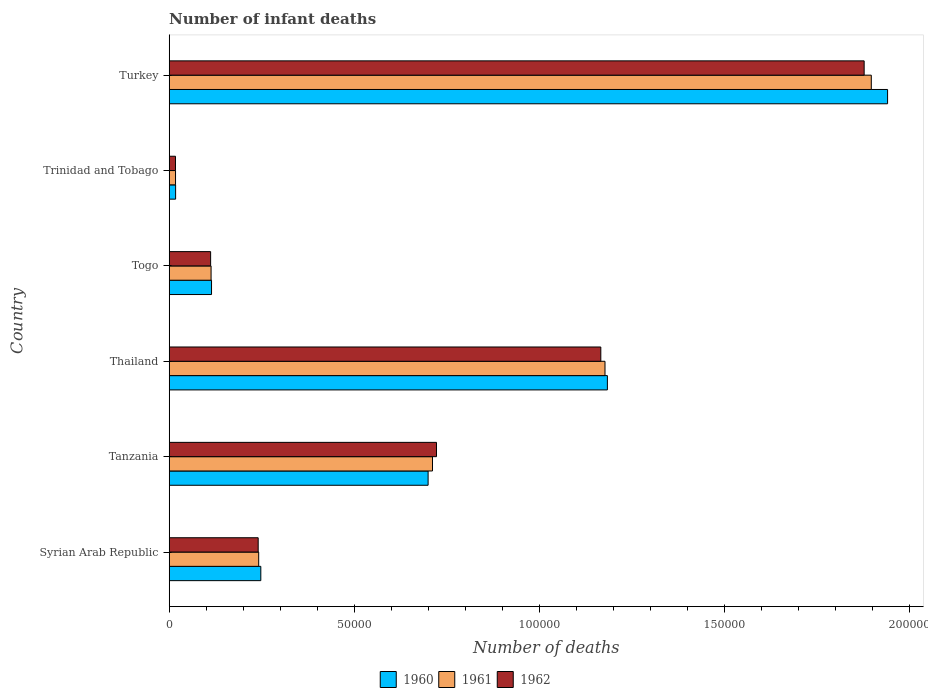How many bars are there on the 2nd tick from the bottom?
Offer a terse response. 3. What is the label of the 2nd group of bars from the top?
Offer a very short reply. Trinidad and Tobago. In how many cases, is the number of bars for a given country not equal to the number of legend labels?
Your answer should be very brief. 0. What is the number of infant deaths in 1961 in Turkey?
Provide a succinct answer. 1.90e+05. Across all countries, what is the maximum number of infant deaths in 1960?
Ensure brevity in your answer.  1.94e+05. Across all countries, what is the minimum number of infant deaths in 1960?
Your answer should be very brief. 1728. In which country was the number of infant deaths in 1962 minimum?
Offer a terse response. Trinidad and Tobago. What is the total number of infant deaths in 1961 in the graph?
Offer a terse response. 4.16e+05. What is the difference between the number of infant deaths in 1961 in Tanzania and that in Trinidad and Tobago?
Ensure brevity in your answer.  6.94e+04. What is the difference between the number of infant deaths in 1960 in Thailand and the number of infant deaths in 1961 in Trinidad and Tobago?
Keep it short and to the point. 1.17e+05. What is the average number of infant deaths in 1961 per country?
Your answer should be compact. 6.93e+04. What is the difference between the number of infant deaths in 1961 and number of infant deaths in 1962 in Tanzania?
Your answer should be compact. -1080. What is the ratio of the number of infant deaths in 1960 in Syrian Arab Republic to that in Thailand?
Offer a very short reply. 0.21. Is the number of infant deaths in 1962 in Syrian Arab Republic less than that in Trinidad and Tobago?
Your response must be concise. No. Is the difference between the number of infant deaths in 1961 in Syrian Arab Republic and Turkey greater than the difference between the number of infant deaths in 1962 in Syrian Arab Republic and Turkey?
Your answer should be compact. No. What is the difference between the highest and the second highest number of infant deaths in 1962?
Offer a very short reply. 7.11e+04. What is the difference between the highest and the lowest number of infant deaths in 1962?
Make the answer very short. 1.86e+05. In how many countries, is the number of infant deaths in 1961 greater than the average number of infant deaths in 1961 taken over all countries?
Keep it short and to the point. 3. Is the sum of the number of infant deaths in 1960 in Tanzania and Trinidad and Tobago greater than the maximum number of infant deaths in 1962 across all countries?
Provide a succinct answer. No. Is it the case that in every country, the sum of the number of infant deaths in 1960 and number of infant deaths in 1961 is greater than the number of infant deaths in 1962?
Offer a terse response. Yes. Are all the bars in the graph horizontal?
Offer a very short reply. Yes. Does the graph contain grids?
Your response must be concise. No. Where does the legend appear in the graph?
Offer a very short reply. Bottom center. What is the title of the graph?
Make the answer very short. Number of infant deaths. What is the label or title of the X-axis?
Offer a terse response. Number of deaths. What is the label or title of the Y-axis?
Give a very brief answer. Country. What is the Number of deaths in 1960 in Syrian Arab Republic?
Provide a succinct answer. 2.47e+04. What is the Number of deaths in 1961 in Syrian Arab Republic?
Offer a very short reply. 2.42e+04. What is the Number of deaths in 1962 in Syrian Arab Republic?
Offer a very short reply. 2.40e+04. What is the Number of deaths of 1960 in Tanzania?
Make the answer very short. 6.99e+04. What is the Number of deaths of 1961 in Tanzania?
Keep it short and to the point. 7.11e+04. What is the Number of deaths of 1962 in Tanzania?
Your response must be concise. 7.22e+04. What is the Number of deaths in 1960 in Thailand?
Provide a succinct answer. 1.18e+05. What is the Number of deaths in 1961 in Thailand?
Give a very brief answer. 1.18e+05. What is the Number of deaths in 1962 in Thailand?
Offer a very short reply. 1.17e+05. What is the Number of deaths of 1960 in Togo?
Your answer should be compact. 1.14e+04. What is the Number of deaths of 1961 in Togo?
Your answer should be compact. 1.13e+04. What is the Number of deaths in 1962 in Togo?
Your answer should be compact. 1.12e+04. What is the Number of deaths in 1960 in Trinidad and Tobago?
Offer a very short reply. 1728. What is the Number of deaths in 1961 in Trinidad and Tobago?
Your response must be concise. 1710. What is the Number of deaths of 1962 in Trinidad and Tobago?
Offer a very short reply. 1698. What is the Number of deaths of 1960 in Turkey?
Make the answer very short. 1.94e+05. What is the Number of deaths in 1961 in Turkey?
Your answer should be very brief. 1.90e+05. What is the Number of deaths in 1962 in Turkey?
Provide a succinct answer. 1.88e+05. Across all countries, what is the maximum Number of deaths of 1960?
Your answer should be compact. 1.94e+05. Across all countries, what is the maximum Number of deaths of 1961?
Offer a terse response. 1.90e+05. Across all countries, what is the maximum Number of deaths of 1962?
Provide a short and direct response. 1.88e+05. Across all countries, what is the minimum Number of deaths of 1960?
Offer a terse response. 1728. Across all countries, what is the minimum Number of deaths of 1961?
Provide a short and direct response. 1710. Across all countries, what is the minimum Number of deaths of 1962?
Your response must be concise. 1698. What is the total Number of deaths of 1960 in the graph?
Give a very brief answer. 4.20e+05. What is the total Number of deaths of 1961 in the graph?
Keep it short and to the point. 4.16e+05. What is the total Number of deaths of 1962 in the graph?
Your response must be concise. 4.13e+05. What is the difference between the Number of deaths in 1960 in Syrian Arab Republic and that in Tanzania?
Offer a terse response. -4.52e+04. What is the difference between the Number of deaths in 1961 in Syrian Arab Republic and that in Tanzania?
Provide a succinct answer. -4.69e+04. What is the difference between the Number of deaths of 1962 in Syrian Arab Republic and that in Tanzania?
Your response must be concise. -4.82e+04. What is the difference between the Number of deaths of 1960 in Syrian Arab Republic and that in Thailand?
Give a very brief answer. -9.36e+04. What is the difference between the Number of deaths in 1961 in Syrian Arab Republic and that in Thailand?
Your answer should be compact. -9.35e+04. What is the difference between the Number of deaths in 1962 in Syrian Arab Republic and that in Thailand?
Offer a terse response. -9.25e+04. What is the difference between the Number of deaths of 1960 in Syrian Arab Republic and that in Togo?
Your answer should be very brief. 1.33e+04. What is the difference between the Number of deaths in 1961 in Syrian Arab Republic and that in Togo?
Your answer should be very brief. 1.29e+04. What is the difference between the Number of deaths of 1962 in Syrian Arab Republic and that in Togo?
Keep it short and to the point. 1.28e+04. What is the difference between the Number of deaths in 1960 in Syrian Arab Republic and that in Trinidad and Tobago?
Ensure brevity in your answer.  2.30e+04. What is the difference between the Number of deaths of 1961 in Syrian Arab Republic and that in Trinidad and Tobago?
Provide a short and direct response. 2.25e+04. What is the difference between the Number of deaths in 1962 in Syrian Arab Republic and that in Trinidad and Tobago?
Your response must be concise. 2.23e+04. What is the difference between the Number of deaths of 1960 in Syrian Arab Republic and that in Turkey?
Your response must be concise. -1.69e+05. What is the difference between the Number of deaths in 1961 in Syrian Arab Republic and that in Turkey?
Ensure brevity in your answer.  -1.65e+05. What is the difference between the Number of deaths of 1962 in Syrian Arab Republic and that in Turkey?
Offer a very short reply. -1.64e+05. What is the difference between the Number of deaths of 1960 in Tanzania and that in Thailand?
Ensure brevity in your answer.  -4.84e+04. What is the difference between the Number of deaths of 1961 in Tanzania and that in Thailand?
Your answer should be compact. -4.66e+04. What is the difference between the Number of deaths of 1962 in Tanzania and that in Thailand?
Provide a succinct answer. -4.44e+04. What is the difference between the Number of deaths of 1960 in Tanzania and that in Togo?
Provide a short and direct response. 5.85e+04. What is the difference between the Number of deaths of 1961 in Tanzania and that in Togo?
Your answer should be compact. 5.98e+04. What is the difference between the Number of deaths of 1962 in Tanzania and that in Togo?
Your response must be concise. 6.10e+04. What is the difference between the Number of deaths of 1960 in Tanzania and that in Trinidad and Tobago?
Keep it short and to the point. 6.82e+04. What is the difference between the Number of deaths in 1961 in Tanzania and that in Trinidad and Tobago?
Your answer should be very brief. 6.94e+04. What is the difference between the Number of deaths in 1962 in Tanzania and that in Trinidad and Tobago?
Provide a succinct answer. 7.05e+04. What is the difference between the Number of deaths in 1960 in Tanzania and that in Turkey?
Your response must be concise. -1.24e+05. What is the difference between the Number of deaths in 1961 in Tanzania and that in Turkey?
Give a very brief answer. -1.19e+05. What is the difference between the Number of deaths in 1962 in Tanzania and that in Turkey?
Your answer should be very brief. -1.16e+05. What is the difference between the Number of deaths of 1960 in Thailand and that in Togo?
Ensure brevity in your answer.  1.07e+05. What is the difference between the Number of deaths in 1961 in Thailand and that in Togo?
Your answer should be very brief. 1.06e+05. What is the difference between the Number of deaths in 1962 in Thailand and that in Togo?
Give a very brief answer. 1.05e+05. What is the difference between the Number of deaths in 1960 in Thailand and that in Trinidad and Tobago?
Make the answer very short. 1.17e+05. What is the difference between the Number of deaths of 1961 in Thailand and that in Trinidad and Tobago?
Keep it short and to the point. 1.16e+05. What is the difference between the Number of deaths of 1962 in Thailand and that in Trinidad and Tobago?
Your answer should be compact. 1.15e+05. What is the difference between the Number of deaths in 1960 in Thailand and that in Turkey?
Keep it short and to the point. -7.57e+04. What is the difference between the Number of deaths in 1961 in Thailand and that in Turkey?
Offer a very short reply. -7.19e+04. What is the difference between the Number of deaths of 1962 in Thailand and that in Turkey?
Offer a terse response. -7.11e+04. What is the difference between the Number of deaths in 1960 in Togo and that in Trinidad and Tobago?
Your response must be concise. 9703. What is the difference between the Number of deaths in 1961 in Togo and that in Trinidad and Tobago?
Your response must be concise. 9601. What is the difference between the Number of deaths in 1962 in Togo and that in Trinidad and Tobago?
Your answer should be compact. 9487. What is the difference between the Number of deaths in 1960 in Togo and that in Turkey?
Make the answer very short. -1.83e+05. What is the difference between the Number of deaths in 1961 in Togo and that in Turkey?
Provide a succinct answer. -1.78e+05. What is the difference between the Number of deaths of 1962 in Togo and that in Turkey?
Offer a very short reply. -1.77e+05. What is the difference between the Number of deaths in 1960 in Trinidad and Tobago and that in Turkey?
Your answer should be very brief. -1.92e+05. What is the difference between the Number of deaths in 1961 in Trinidad and Tobago and that in Turkey?
Your answer should be compact. -1.88e+05. What is the difference between the Number of deaths of 1962 in Trinidad and Tobago and that in Turkey?
Make the answer very short. -1.86e+05. What is the difference between the Number of deaths of 1960 in Syrian Arab Republic and the Number of deaths of 1961 in Tanzania?
Your answer should be very brief. -4.64e+04. What is the difference between the Number of deaths in 1960 in Syrian Arab Republic and the Number of deaths in 1962 in Tanzania?
Your response must be concise. -4.74e+04. What is the difference between the Number of deaths in 1961 in Syrian Arab Republic and the Number of deaths in 1962 in Tanzania?
Give a very brief answer. -4.80e+04. What is the difference between the Number of deaths of 1960 in Syrian Arab Republic and the Number of deaths of 1961 in Thailand?
Offer a very short reply. -9.30e+04. What is the difference between the Number of deaths in 1960 in Syrian Arab Republic and the Number of deaths in 1962 in Thailand?
Keep it short and to the point. -9.18e+04. What is the difference between the Number of deaths in 1961 in Syrian Arab Republic and the Number of deaths in 1962 in Thailand?
Your response must be concise. -9.24e+04. What is the difference between the Number of deaths of 1960 in Syrian Arab Republic and the Number of deaths of 1961 in Togo?
Provide a succinct answer. 1.34e+04. What is the difference between the Number of deaths in 1960 in Syrian Arab Republic and the Number of deaths in 1962 in Togo?
Ensure brevity in your answer.  1.36e+04. What is the difference between the Number of deaths in 1961 in Syrian Arab Republic and the Number of deaths in 1962 in Togo?
Your response must be concise. 1.30e+04. What is the difference between the Number of deaths of 1960 in Syrian Arab Republic and the Number of deaths of 1961 in Trinidad and Tobago?
Keep it short and to the point. 2.30e+04. What is the difference between the Number of deaths in 1960 in Syrian Arab Republic and the Number of deaths in 1962 in Trinidad and Tobago?
Provide a succinct answer. 2.30e+04. What is the difference between the Number of deaths in 1961 in Syrian Arab Republic and the Number of deaths in 1962 in Trinidad and Tobago?
Make the answer very short. 2.25e+04. What is the difference between the Number of deaths of 1960 in Syrian Arab Republic and the Number of deaths of 1961 in Turkey?
Give a very brief answer. -1.65e+05. What is the difference between the Number of deaths of 1960 in Syrian Arab Republic and the Number of deaths of 1962 in Turkey?
Keep it short and to the point. -1.63e+05. What is the difference between the Number of deaths of 1961 in Syrian Arab Republic and the Number of deaths of 1962 in Turkey?
Keep it short and to the point. -1.64e+05. What is the difference between the Number of deaths in 1960 in Tanzania and the Number of deaths in 1961 in Thailand?
Give a very brief answer. -4.78e+04. What is the difference between the Number of deaths in 1960 in Tanzania and the Number of deaths in 1962 in Thailand?
Your response must be concise. -4.66e+04. What is the difference between the Number of deaths in 1961 in Tanzania and the Number of deaths in 1962 in Thailand?
Offer a terse response. -4.55e+04. What is the difference between the Number of deaths in 1960 in Tanzania and the Number of deaths in 1961 in Togo?
Provide a short and direct response. 5.86e+04. What is the difference between the Number of deaths in 1960 in Tanzania and the Number of deaths in 1962 in Togo?
Keep it short and to the point. 5.87e+04. What is the difference between the Number of deaths in 1961 in Tanzania and the Number of deaths in 1962 in Togo?
Ensure brevity in your answer.  5.99e+04. What is the difference between the Number of deaths in 1960 in Tanzania and the Number of deaths in 1961 in Trinidad and Tobago?
Ensure brevity in your answer.  6.82e+04. What is the difference between the Number of deaths in 1960 in Tanzania and the Number of deaths in 1962 in Trinidad and Tobago?
Your response must be concise. 6.82e+04. What is the difference between the Number of deaths in 1961 in Tanzania and the Number of deaths in 1962 in Trinidad and Tobago?
Provide a succinct answer. 6.94e+04. What is the difference between the Number of deaths of 1960 in Tanzania and the Number of deaths of 1961 in Turkey?
Ensure brevity in your answer.  -1.20e+05. What is the difference between the Number of deaths of 1960 in Tanzania and the Number of deaths of 1962 in Turkey?
Provide a short and direct response. -1.18e+05. What is the difference between the Number of deaths in 1961 in Tanzania and the Number of deaths in 1962 in Turkey?
Offer a terse response. -1.17e+05. What is the difference between the Number of deaths of 1960 in Thailand and the Number of deaths of 1961 in Togo?
Your answer should be compact. 1.07e+05. What is the difference between the Number of deaths in 1960 in Thailand and the Number of deaths in 1962 in Togo?
Offer a terse response. 1.07e+05. What is the difference between the Number of deaths of 1961 in Thailand and the Number of deaths of 1962 in Togo?
Offer a terse response. 1.07e+05. What is the difference between the Number of deaths of 1960 in Thailand and the Number of deaths of 1961 in Trinidad and Tobago?
Provide a short and direct response. 1.17e+05. What is the difference between the Number of deaths in 1960 in Thailand and the Number of deaths in 1962 in Trinidad and Tobago?
Offer a very short reply. 1.17e+05. What is the difference between the Number of deaths of 1961 in Thailand and the Number of deaths of 1962 in Trinidad and Tobago?
Give a very brief answer. 1.16e+05. What is the difference between the Number of deaths in 1960 in Thailand and the Number of deaths in 1961 in Turkey?
Your answer should be very brief. -7.13e+04. What is the difference between the Number of deaths of 1960 in Thailand and the Number of deaths of 1962 in Turkey?
Make the answer very short. -6.93e+04. What is the difference between the Number of deaths in 1961 in Thailand and the Number of deaths in 1962 in Turkey?
Ensure brevity in your answer.  -7.00e+04. What is the difference between the Number of deaths in 1960 in Togo and the Number of deaths in 1961 in Trinidad and Tobago?
Your answer should be very brief. 9721. What is the difference between the Number of deaths of 1960 in Togo and the Number of deaths of 1962 in Trinidad and Tobago?
Your answer should be very brief. 9733. What is the difference between the Number of deaths of 1961 in Togo and the Number of deaths of 1962 in Trinidad and Tobago?
Offer a terse response. 9613. What is the difference between the Number of deaths of 1960 in Togo and the Number of deaths of 1961 in Turkey?
Your answer should be compact. -1.78e+05. What is the difference between the Number of deaths of 1960 in Togo and the Number of deaths of 1962 in Turkey?
Give a very brief answer. -1.76e+05. What is the difference between the Number of deaths in 1961 in Togo and the Number of deaths in 1962 in Turkey?
Offer a terse response. -1.76e+05. What is the difference between the Number of deaths of 1960 in Trinidad and Tobago and the Number of deaths of 1961 in Turkey?
Your answer should be compact. -1.88e+05. What is the difference between the Number of deaths in 1960 in Trinidad and Tobago and the Number of deaths in 1962 in Turkey?
Provide a succinct answer. -1.86e+05. What is the difference between the Number of deaths in 1961 in Trinidad and Tobago and the Number of deaths in 1962 in Turkey?
Provide a succinct answer. -1.86e+05. What is the average Number of deaths in 1960 per country?
Provide a succinct answer. 7.00e+04. What is the average Number of deaths of 1961 per country?
Ensure brevity in your answer.  6.93e+04. What is the average Number of deaths of 1962 per country?
Provide a succinct answer. 6.89e+04. What is the difference between the Number of deaths of 1960 and Number of deaths of 1961 in Syrian Arab Republic?
Offer a terse response. 572. What is the difference between the Number of deaths of 1960 and Number of deaths of 1962 in Syrian Arab Republic?
Provide a short and direct response. 711. What is the difference between the Number of deaths of 1961 and Number of deaths of 1962 in Syrian Arab Republic?
Offer a very short reply. 139. What is the difference between the Number of deaths of 1960 and Number of deaths of 1961 in Tanzania?
Your response must be concise. -1186. What is the difference between the Number of deaths of 1960 and Number of deaths of 1962 in Tanzania?
Offer a terse response. -2266. What is the difference between the Number of deaths of 1961 and Number of deaths of 1962 in Tanzania?
Offer a terse response. -1080. What is the difference between the Number of deaths of 1960 and Number of deaths of 1961 in Thailand?
Give a very brief answer. 643. What is the difference between the Number of deaths of 1960 and Number of deaths of 1962 in Thailand?
Make the answer very short. 1775. What is the difference between the Number of deaths of 1961 and Number of deaths of 1962 in Thailand?
Make the answer very short. 1132. What is the difference between the Number of deaths in 1960 and Number of deaths in 1961 in Togo?
Offer a terse response. 120. What is the difference between the Number of deaths of 1960 and Number of deaths of 1962 in Togo?
Your answer should be compact. 246. What is the difference between the Number of deaths of 1961 and Number of deaths of 1962 in Togo?
Your response must be concise. 126. What is the difference between the Number of deaths of 1960 and Number of deaths of 1961 in Trinidad and Tobago?
Your answer should be compact. 18. What is the difference between the Number of deaths in 1960 and Number of deaths in 1962 in Trinidad and Tobago?
Ensure brevity in your answer.  30. What is the difference between the Number of deaths in 1961 and Number of deaths in 1962 in Trinidad and Tobago?
Keep it short and to the point. 12. What is the difference between the Number of deaths of 1960 and Number of deaths of 1961 in Turkey?
Provide a succinct answer. 4395. What is the difference between the Number of deaths of 1960 and Number of deaths of 1962 in Turkey?
Your answer should be very brief. 6326. What is the difference between the Number of deaths of 1961 and Number of deaths of 1962 in Turkey?
Your response must be concise. 1931. What is the ratio of the Number of deaths in 1960 in Syrian Arab Republic to that in Tanzania?
Give a very brief answer. 0.35. What is the ratio of the Number of deaths in 1961 in Syrian Arab Republic to that in Tanzania?
Ensure brevity in your answer.  0.34. What is the ratio of the Number of deaths of 1962 in Syrian Arab Republic to that in Tanzania?
Your answer should be very brief. 0.33. What is the ratio of the Number of deaths of 1960 in Syrian Arab Republic to that in Thailand?
Give a very brief answer. 0.21. What is the ratio of the Number of deaths in 1961 in Syrian Arab Republic to that in Thailand?
Ensure brevity in your answer.  0.21. What is the ratio of the Number of deaths of 1962 in Syrian Arab Republic to that in Thailand?
Offer a terse response. 0.21. What is the ratio of the Number of deaths in 1960 in Syrian Arab Republic to that in Togo?
Keep it short and to the point. 2.16. What is the ratio of the Number of deaths of 1961 in Syrian Arab Republic to that in Togo?
Your answer should be very brief. 2.14. What is the ratio of the Number of deaths in 1962 in Syrian Arab Republic to that in Togo?
Offer a terse response. 2.15. What is the ratio of the Number of deaths of 1960 in Syrian Arab Republic to that in Trinidad and Tobago?
Give a very brief answer. 14.32. What is the ratio of the Number of deaths in 1961 in Syrian Arab Republic to that in Trinidad and Tobago?
Ensure brevity in your answer.  14.13. What is the ratio of the Number of deaths of 1962 in Syrian Arab Republic to that in Trinidad and Tobago?
Offer a terse response. 14.15. What is the ratio of the Number of deaths of 1960 in Syrian Arab Republic to that in Turkey?
Offer a very short reply. 0.13. What is the ratio of the Number of deaths in 1961 in Syrian Arab Republic to that in Turkey?
Provide a short and direct response. 0.13. What is the ratio of the Number of deaths in 1962 in Syrian Arab Republic to that in Turkey?
Provide a succinct answer. 0.13. What is the ratio of the Number of deaths of 1960 in Tanzania to that in Thailand?
Keep it short and to the point. 0.59. What is the ratio of the Number of deaths in 1961 in Tanzania to that in Thailand?
Make the answer very short. 0.6. What is the ratio of the Number of deaths of 1962 in Tanzania to that in Thailand?
Offer a terse response. 0.62. What is the ratio of the Number of deaths in 1960 in Tanzania to that in Togo?
Your answer should be very brief. 6.12. What is the ratio of the Number of deaths of 1961 in Tanzania to that in Togo?
Make the answer very short. 6.29. What is the ratio of the Number of deaths of 1962 in Tanzania to that in Togo?
Ensure brevity in your answer.  6.45. What is the ratio of the Number of deaths in 1960 in Tanzania to that in Trinidad and Tobago?
Provide a short and direct response. 40.47. What is the ratio of the Number of deaths of 1961 in Tanzania to that in Trinidad and Tobago?
Offer a very short reply. 41.59. What is the ratio of the Number of deaths of 1962 in Tanzania to that in Trinidad and Tobago?
Your answer should be very brief. 42.52. What is the ratio of the Number of deaths of 1960 in Tanzania to that in Turkey?
Your answer should be compact. 0.36. What is the ratio of the Number of deaths in 1962 in Tanzania to that in Turkey?
Make the answer very short. 0.38. What is the ratio of the Number of deaths in 1960 in Thailand to that in Togo?
Your response must be concise. 10.35. What is the ratio of the Number of deaths in 1961 in Thailand to that in Togo?
Keep it short and to the point. 10.41. What is the ratio of the Number of deaths of 1962 in Thailand to that in Togo?
Provide a succinct answer. 10.42. What is the ratio of the Number of deaths in 1960 in Thailand to that in Trinidad and Tobago?
Your answer should be compact. 68.49. What is the ratio of the Number of deaths in 1961 in Thailand to that in Trinidad and Tobago?
Ensure brevity in your answer.  68.83. What is the ratio of the Number of deaths in 1962 in Thailand to that in Trinidad and Tobago?
Offer a very short reply. 68.65. What is the ratio of the Number of deaths of 1960 in Thailand to that in Turkey?
Provide a succinct answer. 0.61. What is the ratio of the Number of deaths in 1961 in Thailand to that in Turkey?
Offer a terse response. 0.62. What is the ratio of the Number of deaths of 1962 in Thailand to that in Turkey?
Provide a short and direct response. 0.62. What is the ratio of the Number of deaths in 1960 in Togo to that in Trinidad and Tobago?
Provide a short and direct response. 6.62. What is the ratio of the Number of deaths in 1961 in Togo to that in Trinidad and Tobago?
Make the answer very short. 6.61. What is the ratio of the Number of deaths in 1962 in Togo to that in Trinidad and Tobago?
Provide a short and direct response. 6.59. What is the ratio of the Number of deaths of 1960 in Togo to that in Turkey?
Your answer should be very brief. 0.06. What is the ratio of the Number of deaths of 1961 in Togo to that in Turkey?
Offer a terse response. 0.06. What is the ratio of the Number of deaths of 1962 in Togo to that in Turkey?
Give a very brief answer. 0.06. What is the ratio of the Number of deaths in 1960 in Trinidad and Tobago to that in Turkey?
Provide a short and direct response. 0.01. What is the ratio of the Number of deaths in 1961 in Trinidad and Tobago to that in Turkey?
Offer a very short reply. 0.01. What is the ratio of the Number of deaths in 1962 in Trinidad and Tobago to that in Turkey?
Offer a very short reply. 0.01. What is the difference between the highest and the second highest Number of deaths in 1960?
Your answer should be compact. 7.57e+04. What is the difference between the highest and the second highest Number of deaths in 1961?
Keep it short and to the point. 7.19e+04. What is the difference between the highest and the second highest Number of deaths of 1962?
Make the answer very short. 7.11e+04. What is the difference between the highest and the lowest Number of deaths in 1960?
Keep it short and to the point. 1.92e+05. What is the difference between the highest and the lowest Number of deaths in 1961?
Offer a terse response. 1.88e+05. What is the difference between the highest and the lowest Number of deaths in 1962?
Offer a terse response. 1.86e+05. 